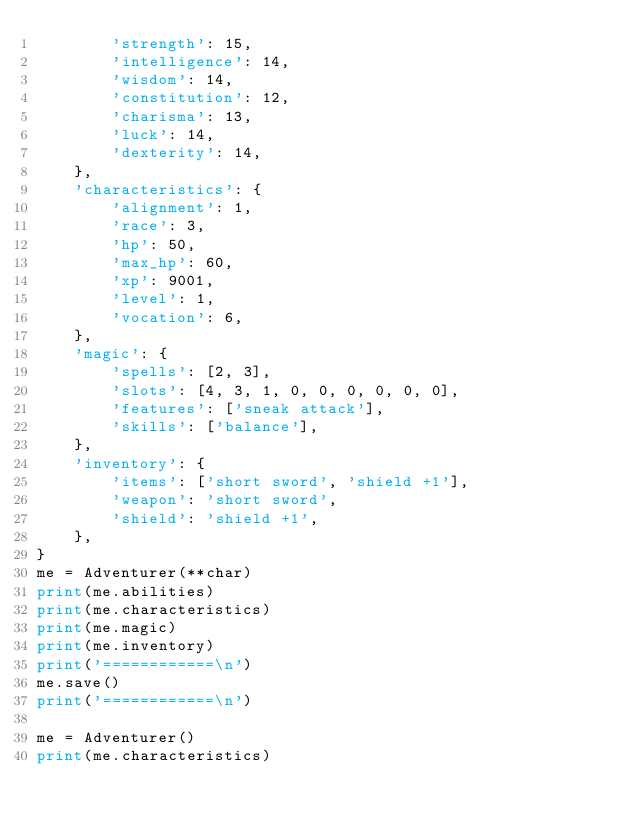<code> <loc_0><loc_0><loc_500><loc_500><_Python_>        'strength': 15,
        'intelligence': 14,
        'wisdom': 14,
        'constitution': 12,
        'charisma': 13,
        'luck': 14,
        'dexterity': 14,
    },
    'characteristics': {
        'alignment': 1,
        'race': 3,
        'hp': 50,
        'max_hp': 60,
        'xp': 9001,
        'level': 1,
        'vocation': 6,
    },
    'magic': {
        'spells': [2, 3],
        'slots': [4, 3, 1, 0, 0, 0, 0, 0, 0],
        'features': ['sneak attack'],
        'skills': ['balance'],
    },
    'inventory': {
        'items': ['short sword', 'shield +1'],
        'weapon': 'short sword',
        'shield': 'shield +1',
    },
}
me = Adventurer(**char)
print(me.abilities)
print(me.characteristics)
print(me.magic)
print(me.inventory)
print('============\n')
me.save()
print('============\n')

me = Adventurer()
print(me.characteristics)
</code> 